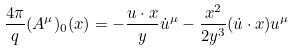Convert formula to latex. <formula><loc_0><loc_0><loc_500><loc_500>\frac { 4 \pi } { q } ( A ^ { \mu } ) _ { 0 } ( x ) = - \frac { u \cdot x } { y } \dot { u } ^ { \mu } - \frac { x ^ { 2 } } { 2 y ^ { 3 } } ( \dot { u } \cdot x ) u ^ { \mu }</formula> 